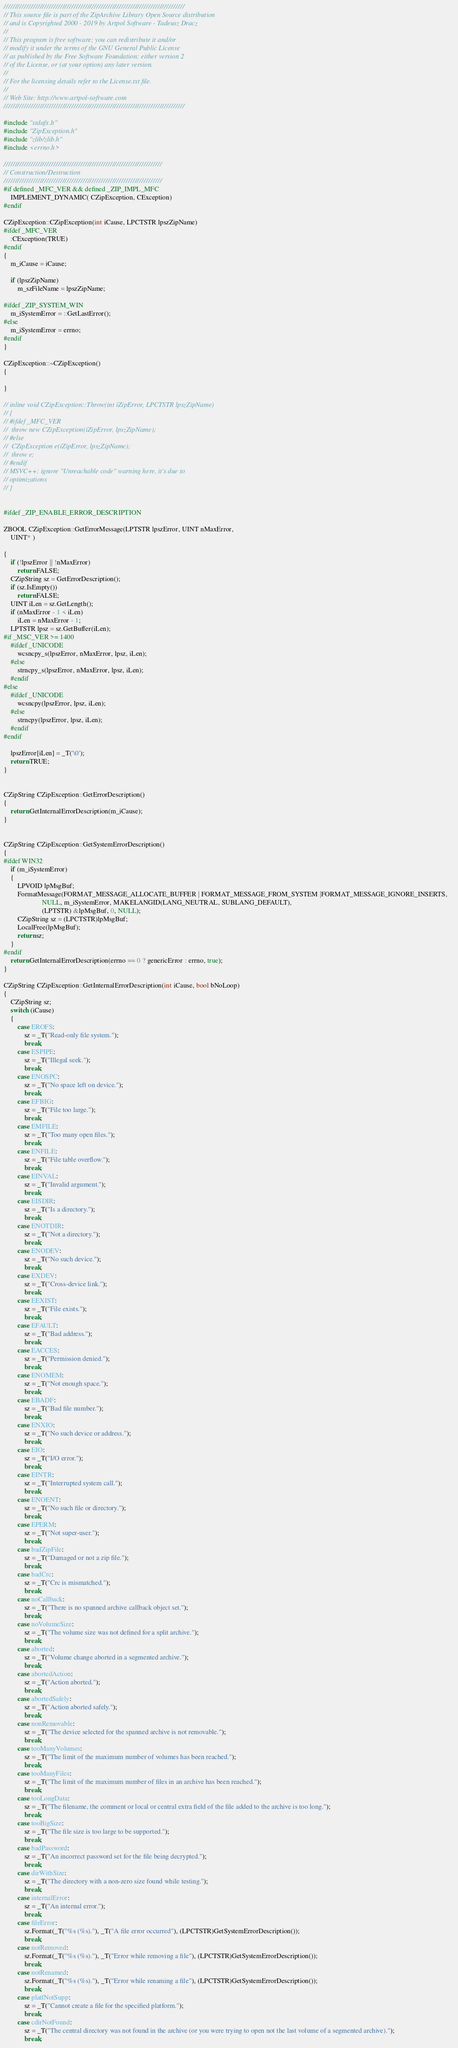Convert code to text. <code><loc_0><loc_0><loc_500><loc_500><_C++_>////////////////////////////////////////////////////////////////////////////////
// This source file is part of the ZipArchive Library Open Source distribution 
// and is Copyrighted 2000 - 2019 by Artpol Software - Tadeusz Dracz
//
// This program is free software; you can redistribute it and/or
// modify it under the terms of the GNU General Public License
// as published by the Free Software Foundation; either version 2
// of the License, or (at your option) any later version.
// 
// For the licensing details refer to the License.txt file.
//
// Web Site: http://www.artpol-software.com
////////////////////////////////////////////////////////////////////////////////

#include "stdafx.h"
#include "ZipException.h"
#include "zlib/zlib.h"
#include <errno.h>

//////////////////////////////////////////////////////////////////////
// Construction/Destruction
//////////////////////////////////////////////////////////////////////
#if defined _MFC_VER && defined _ZIP_IMPL_MFC
	IMPLEMENT_DYNAMIC( CZipException, CException)
#endif

CZipException::CZipException(int iCause, LPCTSTR lpszZipName)
#ifdef _MFC_VER
	:CException(TRUE)
#endif
{
	m_iCause = iCause;

	if (lpszZipName)
		m_szFileName = lpszZipName;

#ifdef _ZIP_SYSTEM_WIN
	m_iSystemError = ::GetLastError();
#else
	m_iSystemError = errno;
#endif
}

CZipException::~CZipException()
{

}

// inline void CZipException::Throw(int iZipError, LPCTSTR lpszZipName)
// {
// #ifdef _MFC_VER
// 	throw new CZipException(iZipError, lpszZipName);
// #else
// 	CZipException e(iZipError, lpszZipName);
// 	throw e;
// #endif
// MSVC++: ignore "Unreachable code" warning here, it's due to 
// optimizations
// }


#ifdef _ZIP_ENABLE_ERROR_DESCRIPTION

ZBOOL CZipException::GetErrorMessage(LPTSTR lpszError, UINT nMaxError,
	UINT* )

{
	if (!lpszError || !nMaxError)
		return FALSE;
	CZipString sz = GetErrorDescription();
	if (sz.IsEmpty())
		return FALSE;
	UINT iLen = sz.GetLength();
	if (nMaxError - 1 < iLen)
		iLen = nMaxError - 1;
	LPTSTR lpsz = sz.GetBuffer(iLen);
#if _MSC_VER >= 1400
	#ifdef _UNICODE	
		wcsncpy_s(lpszError, nMaxError, lpsz, iLen);
	#else
		strncpy_s(lpszError, nMaxError, lpsz, iLen);
	#endif
#else
	#ifdef _UNICODE	
		wcsncpy(lpszError, lpsz, iLen);
	#else
		strncpy(lpszError, lpsz, iLen);
	#endif
#endif

	lpszError[iLen] = _T('\0');
	return TRUE;
}


CZipString CZipException::GetErrorDescription()
{
	return GetInternalErrorDescription(m_iCause);
}


CZipString CZipException::GetSystemErrorDescription()
{
#ifdef WIN32	
	if (m_iSystemError)
	{
		LPVOID lpMsgBuf;
		FormatMessage(FORMAT_MESSAGE_ALLOCATE_BUFFER | FORMAT_MESSAGE_FROM_SYSTEM |FORMAT_MESSAGE_IGNORE_INSERTS,    
			          NULL, m_iSystemError, MAKELANGID(LANG_NEUTRAL, SUBLANG_DEFAULT), 
				      (LPTSTR) &lpMsgBuf, 0, NULL);
		CZipString sz = (LPCTSTR)lpMsgBuf;
		LocalFree(lpMsgBuf);
		return sz;
	}
#endif
	return GetInternalErrorDescription(errno == 0 ? genericError : errno, true);
}

CZipString CZipException::GetInternalErrorDescription(int iCause, bool bNoLoop)
{
	CZipString sz;
	switch (iCause)
	{
		case EROFS:
			sz = _T("Read-only file system.");
			break;
		case ESPIPE:
			sz = _T("Illegal seek.");
			break;
		case ENOSPC:
			sz = _T("No space left on device.");
			break;
		case EFBIG:
			sz = _T("File too large.");
			break;
		case EMFILE:
			sz = _T("Too many open files.");
			break;
		case ENFILE:
			sz = _T("File table overflow.");
			break;
		case EINVAL:
			sz = _T("Invalid argument.");
			break;
		case EISDIR:
			sz = _T("Is a directory.");
			break;
		case ENOTDIR:
			sz = _T("Not a directory.");
			break;
		case ENODEV:
			sz = _T("No such device.");
			break;
		case EXDEV:
			sz = _T("Cross-device link.");
			break;
		case EEXIST:
			sz = _T("File exists.");
			break;
		case EFAULT:
			sz = _T("Bad address.");
			break;
		case EACCES:
			sz = _T("Permission denied.");
			break;
		case ENOMEM:
			sz = _T("Not enough space.");
			break;
		case EBADF:
			sz = _T("Bad file number.");
			break;
		case ENXIO:
			sz = _T("No such device or address.");
			break;
		case EIO:
			sz = _T("I/O error.");
			break;
		case EINTR:
			sz = _T("Interrupted system call.");
			break;
		case ENOENT:
			sz = _T("No such file or directory.");
			break;
		case EPERM:
			sz = _T("Not super-user.");
			break;
		case badZipFile:
			sz = _T("Damaged or not a zip file.");
			break;
		case badCrc:
			sz = _T("Crc is mismatched.");
			break;
		case noCallback:
			sz = _T("There is no spanned archive callback object set.");
			break;
		case noVolumeSize:
			sz = _T("The volume size was not defined for a split archive.");
			break;
		case aborted:
			sz = _T("Volume change aborted in a segmented archive.");
			break;
		case abortedAction:
			sz = _T("Action aborted.");
			break;
		case abortedSafely:
			sz = _T("Action aborted safely.");
			break;
		case nonRemovable:
			sz = _T("The device selected for the spanned archive is not removable.");
			break;
		case tooManyVolumes:
			sz = _T("The limit of the maximum number of volumes has been reached.");
			break;
		case tooManyFiles:
			sz = _T("The limit of the maximum number of files in an archive has been reached.");
			break;
		case tooLongData:
			sz = _T("The filename, the comment or local or central extra field of the file added to the archive is too long.");
			break;
		case tooBigSize:
			sz = _T("The file size is too large to be supported.");
			break;
		case badPassword:
			sz = _T("An incorrect password set for the file being decrypted.");
			break;
		case dirWithSize:
			sz = _T("The directory with a non-zero size found while testing.");
			break;
		case internalError:
			sz = _T("An internal error.");
			break;
		case fileError:
			sz.Format(_T("%s (%s)."), _T("A file error occurred"), (LPCTSTR)GetSystemErrorDescription());
			break;
		case notRemoved:
			sz.Format(_T("%s (%s)."), _T("Error while removing a file"), (LPCTSTR)GetSystemErrorDescription());
			break;
		case notRenamed:
			sz.Format(_T("%s (%s)."), _T("Error while renaming a file"), (LPCTSTR)GetSystemErrorDescription());
			break;
		case platfNotSupp:
			sz = _T("Cannot create a file for the specified platform.");
			break;
		case cdirNotFound:
			sz = _T("The central directory was not found in the archive (or you were trying to open not the last volume of a segmented archive).");
			break;</code> 